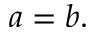Convert formula to latex. <formula><loc_0><loc_0><loc_500><loc_500>a = b .</formula> 